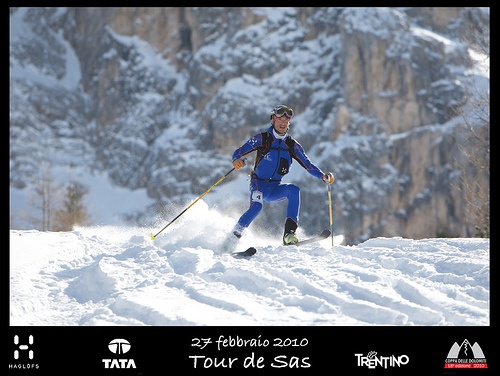Describe the objects in this image and their specific colors. I can see people in black, darkblue, navy, and blue tones and skis in black, lightgray, darkgray, and gray tones in this image. 